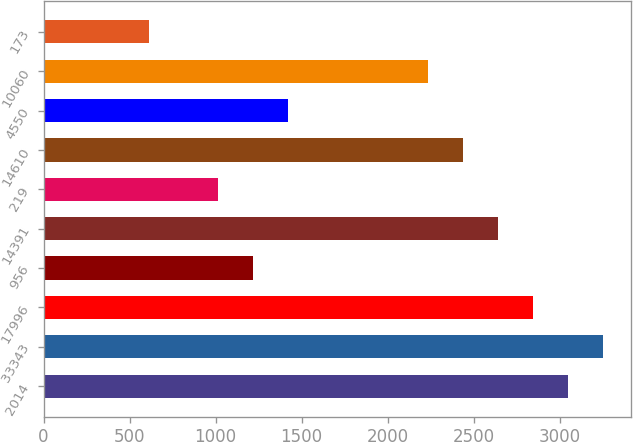Convert chart to OTSL. <chart><loc_0><loc_0><loc_500><loc_500><bar_chart><fcel>2014<fcel>33343<fcel>17996<fcel>956<fcel>14391<fcel>219<fcel>14610<fcel>4550<fcel>10060<fcel>173<nl><fcel>3047.83<fcel>3250.99<fcel>2844.67<fcel>1219.39<fcel>2641.51<fcel>1016.23<fcel>2438.35<fcel>1422.55<fcel>2235.19<fcel>609.91<nl></chart> 